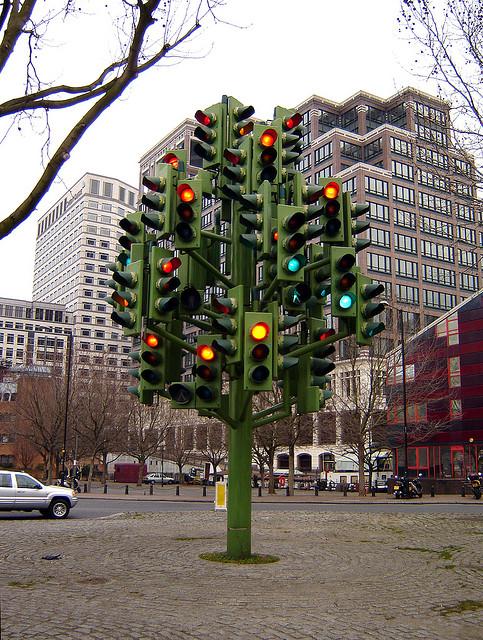Does this appear to be a noisy environment?
Keep it brief. No. Is this too many traffic lights?
Concise answer only. Yes. What is the purpose of this structure?
Quick response, please. Art. 